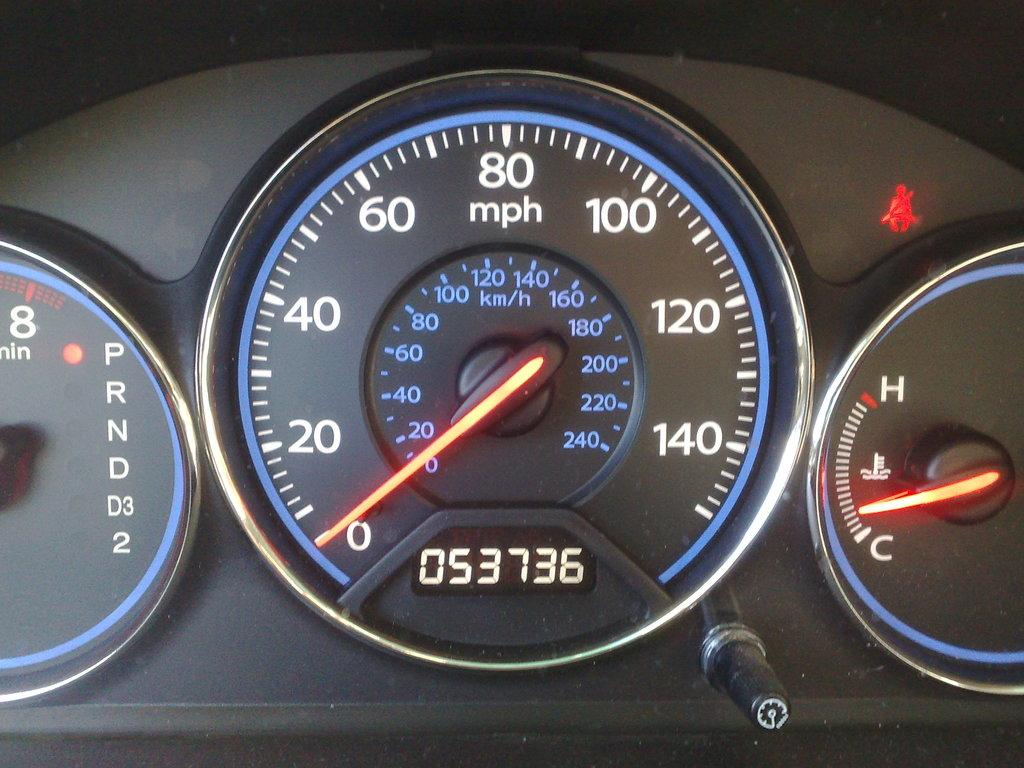What type of instrument is present in the image? There is a speedometer, a fuel meter, and a tachometer in the image. What function do these instruments serve? These instruments are used to measure speed, fuel level, and engine revolutions, respectively. Is there any other notable feature at the bottom of the image? Yes, there is a button at the bottom of the image. What type of fiction is being read by the class in the image? There is no class or fiction present in the image; it only features instruments related to a vehicle. 